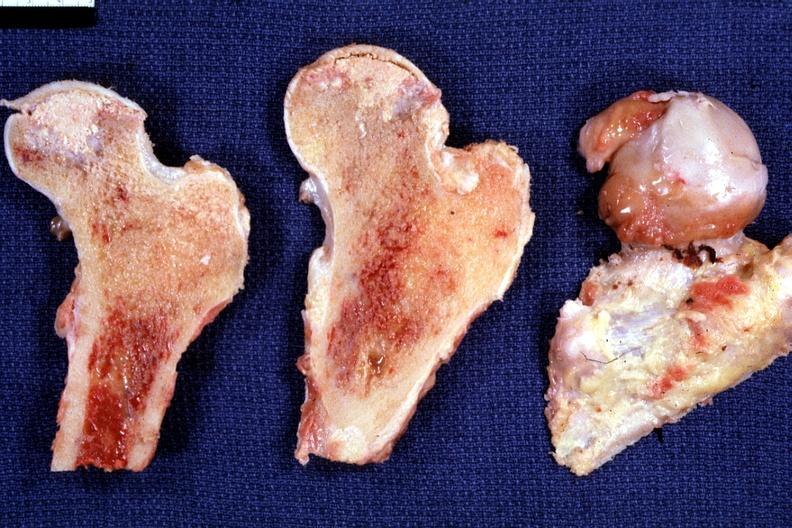what does this image show?
Answer the question using a single word or phrase. Fixed tissue nice photo showing focal osteonecrosis in the femoral head 